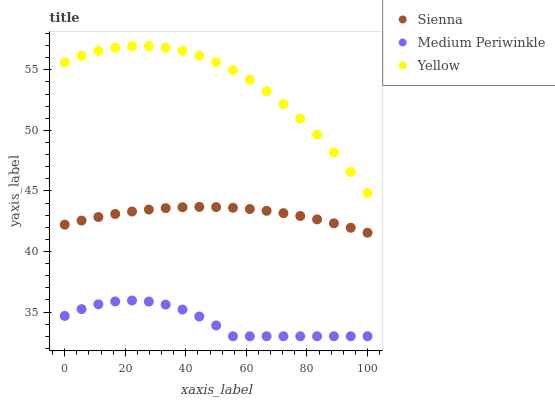Does Medium Periwinkle have the minimum area under the curve?
Answer yes or no. Yes. Does Yellow have the maximum area under the curve?
Answer yes or no. Yes. Does Yellow have the minimum area under the curve?
Answer yes or no. No. Does Medium Periwinkle have the maximum area under the curve?
Answer yes or no. No. Is Sienna the smoothest?
Answer yes or no. Yes. Is Medium Periwinkle the roughest?
Answer yes or no. Yes. Is Yellow the smoothest?
Answer yes or no. No. Is Yellow the roughest?
Answer yes or no. No. Does Medium Periwinkle have the lowest value?
Answer yes or no. Yes. Does Yellow have the lowest value?
Answer yes or no. No. Does Yellow have the highest value?
Answer yes or no. Yes. Does Medium Periwinkle have the highest value?
Answer yes or no. No. Is Medium Periwinkle less than Sienna?
Answer yes or no. Yes. Is Yellow greater than Medium Periwinkle?
Answer yes or no. Yes. Does Medium Periwinkle intersect Sienna?
Answer yes or no. No. 